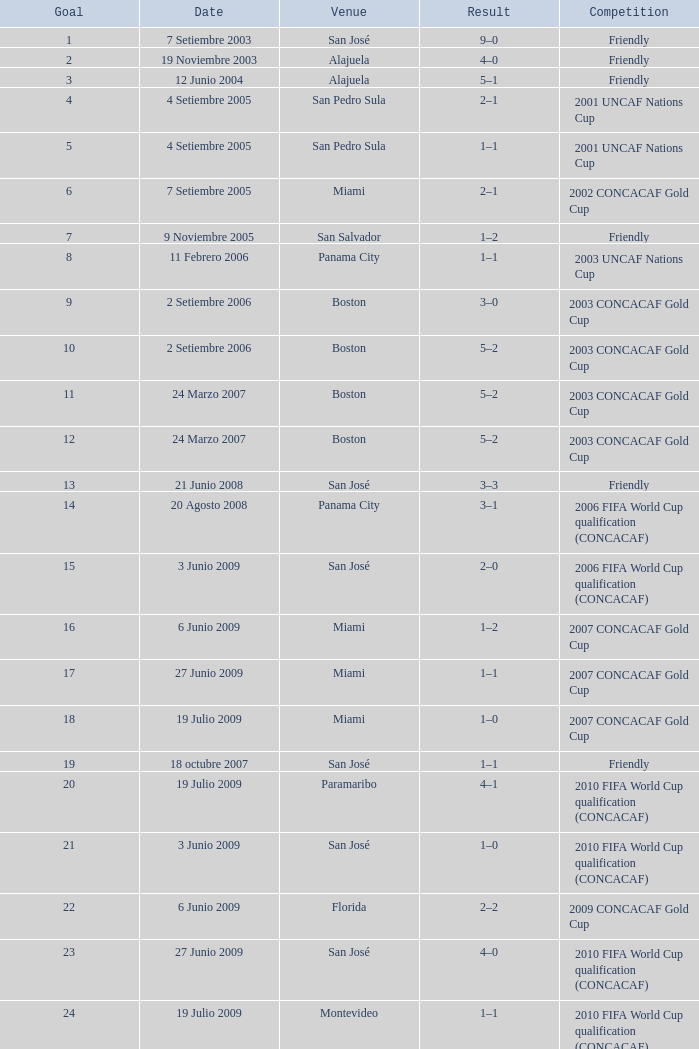Can you describe the event where a total of 6 goals were achieved? 2002 CONCACAF Gold Cup. 